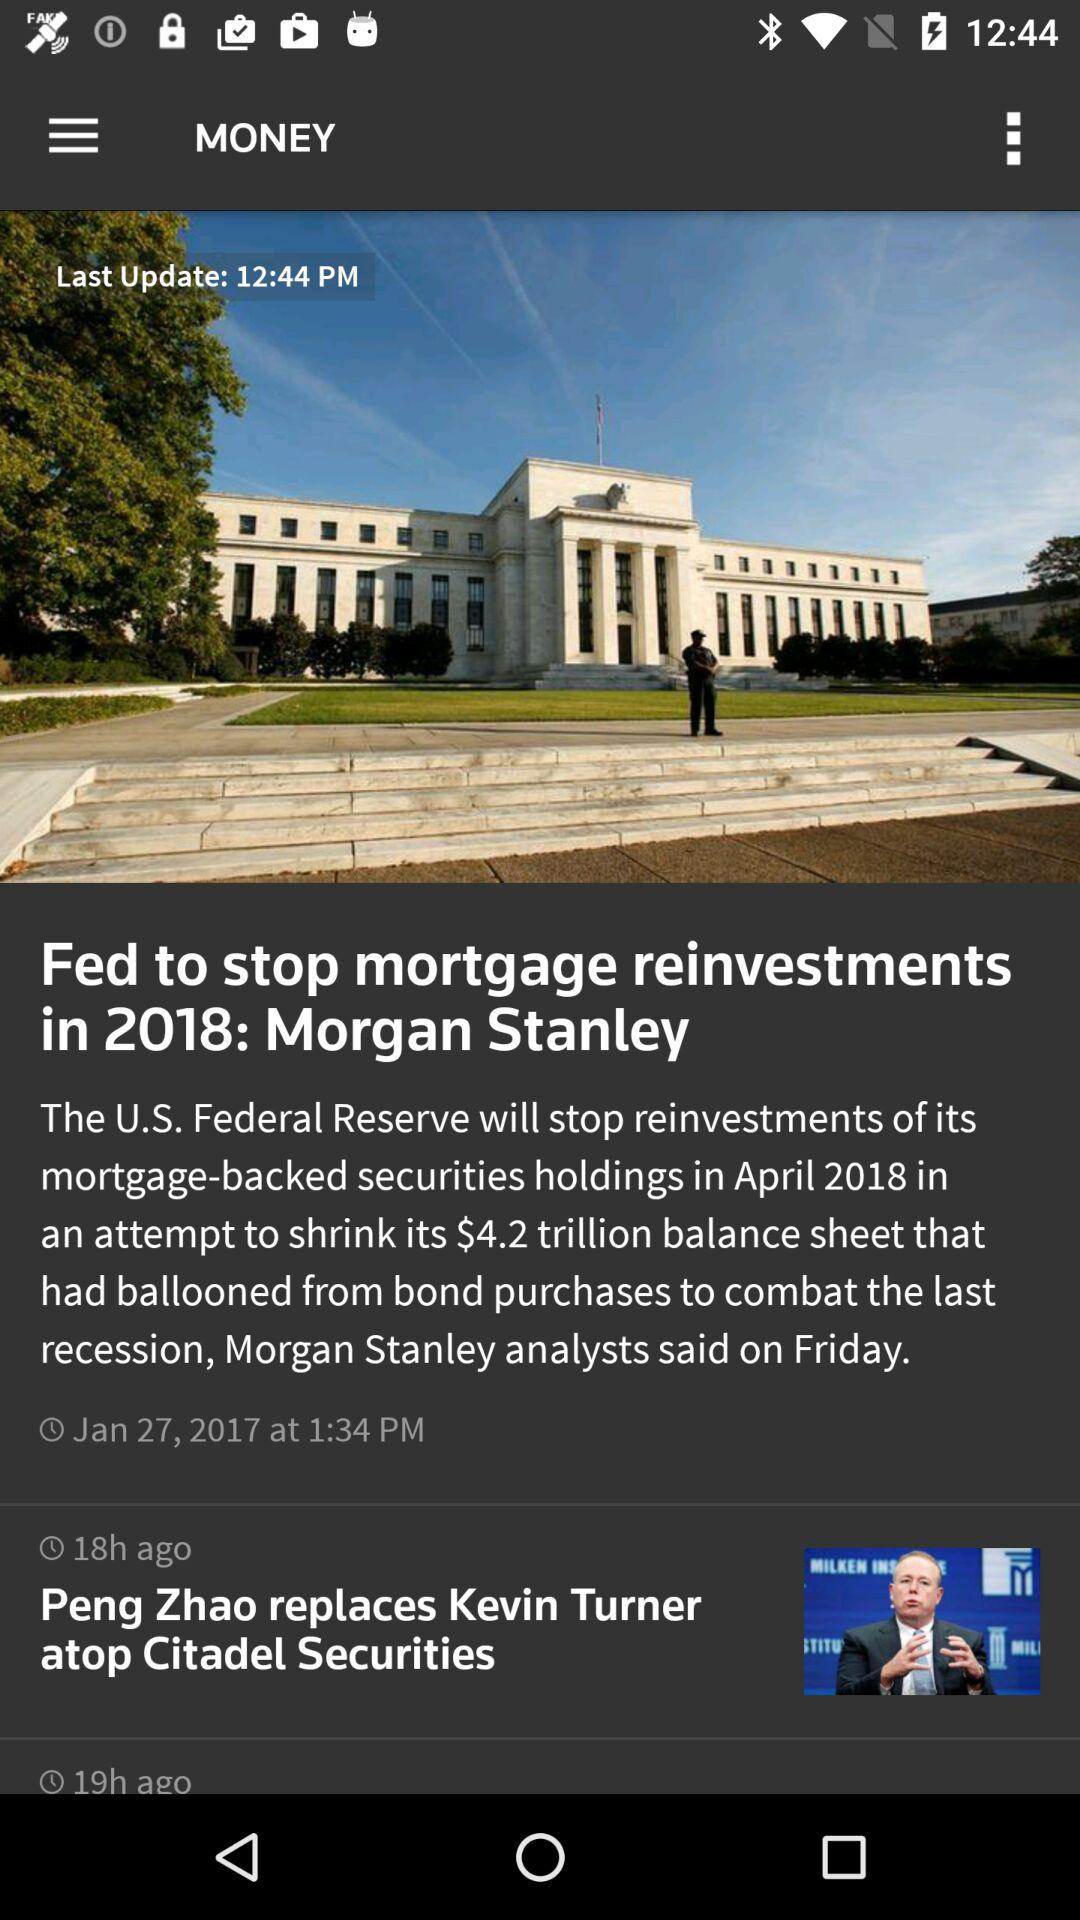What is the date? The date is January 27, 2017. 